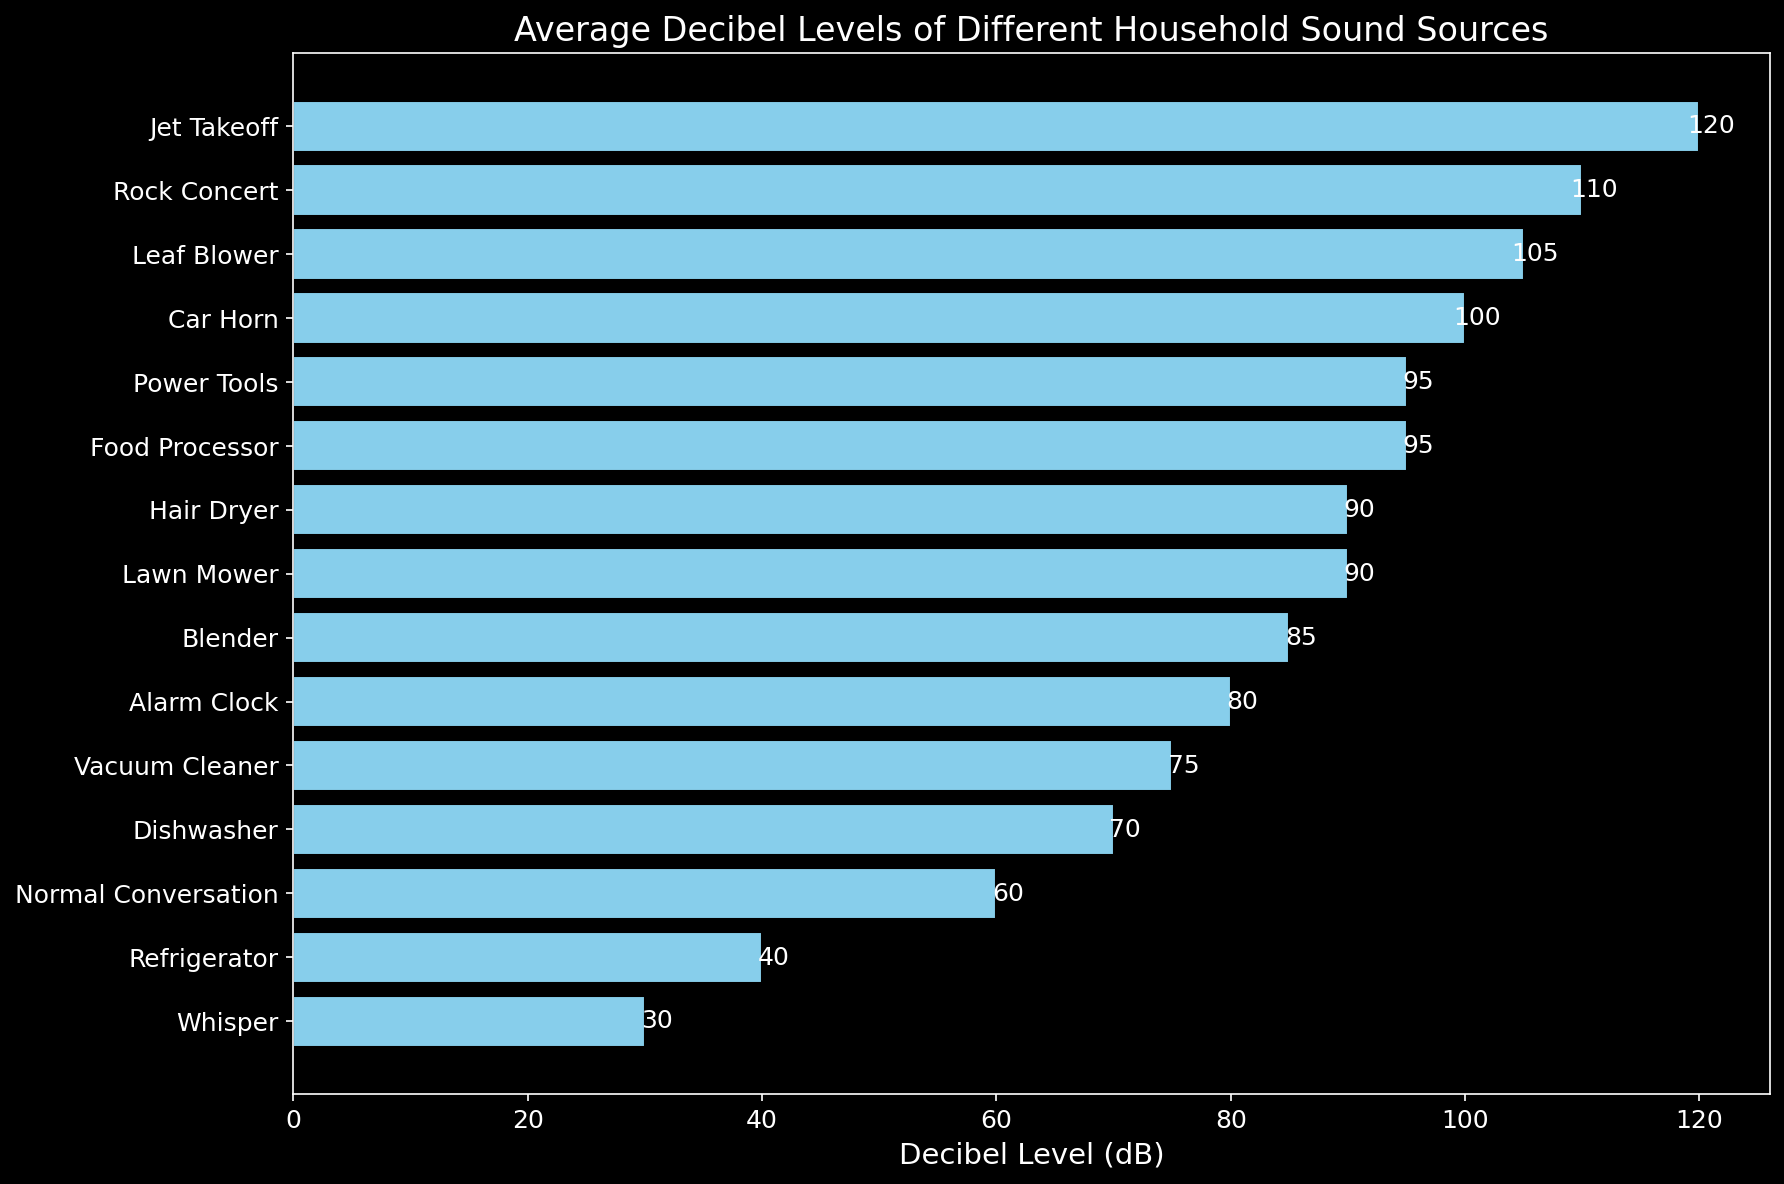What is the decibel level of a refrigerator? Look at the bar labeled "Refrigerator." The corresponding bar's length represents its decibel level.
Answer: 40 dB Which sound source has the highest decibel level? Identify the bar that stretches the furthest to the right. The label next to that bar is the corresponding sound source.
Answer: Jet Takeoff How does the decibel level of a lawn mower compare to that of a normal conversation? Locate the bars for "Lawn Mower" and "Normal Conversation." Compare their lengths to determine which one is longer.
Answer: Lawn Mower is louder Which sound sources have a decibel level equal to or above 100 dB? Identify the bars that extend to 100 dB or more and list their labels.
Answer: Car Horn, Leaf Blower, Rock Concert, Jet Takeoff What is the difference in decibel levels between a whisper and a food processor? Find the decibel levels of both "Whisper" and "Food Processor," and subtract the smaller value from the larger one.
Answer: 65 dB What is the average decibel level of a dishwasher and a vacuum cleaner combined? Determine the decibel levels of both "Dishwasher" and "Vacuum Cleaner." Sum these values and divide by 2.
Answer: 72.5 dB Which is louder, an alarm clock or a blender? Compare the lengths of the bars for "Alarm Clock" and "Blender." Identify which one extends farther to the right.
Answer: Blender How many sound sources have a decibel level higher than 90 dB? Count the number of bars that extend beyond the 90 dB mark.
Answer: 5 Are there any sound sources with the same decibel level? If so, which ones? Look for bars with the same length, representing identical decibel levels, and read their labels.
Answer: Lawn Mower and Hair Dryer; Food Processor and Power Tools What is the total decibel level of the three quietest sound sources? Identify the three shortest bars representing the quietest sound sources, sum their decibel values.
Answer: 130 dB 